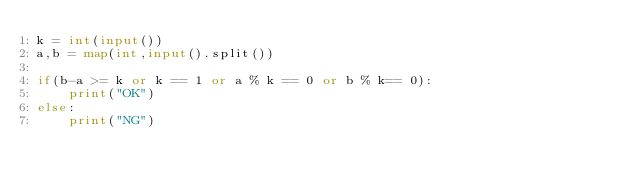Convert code to text. <code><loc_0><loc_0><loc_500><loc_500><_Python_>k = int(input())
a,b = map(int,input().split())

if(b-a >= k or k == 1 or a % k == 0 or b % k== 0):
    print("OK")
else:
    print("NG")</code> 